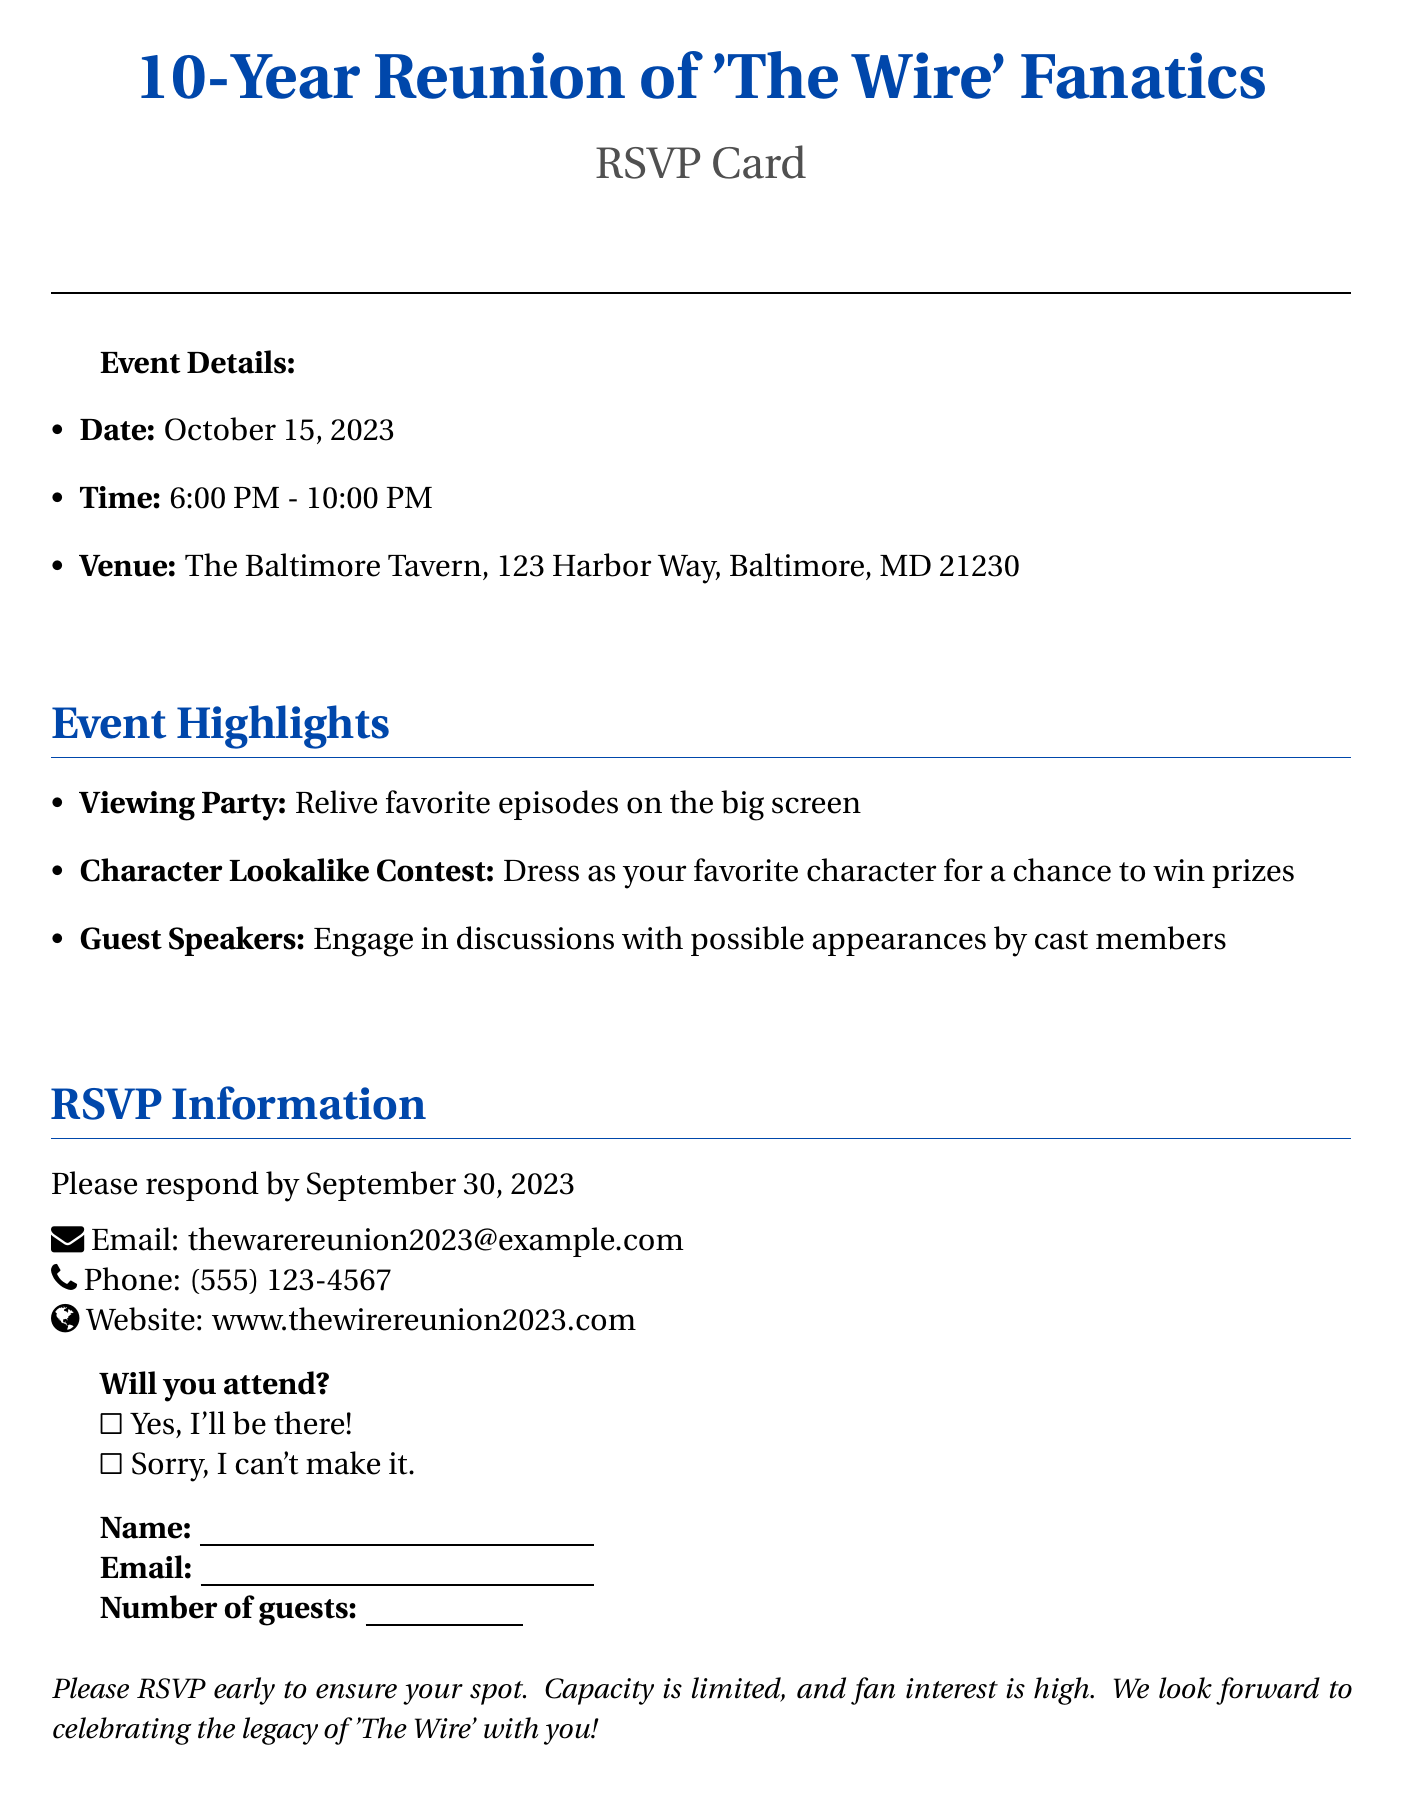What is the date of the reunion? The document specifies the event date as October 15, 2023.
Answer: October 15, 2023 What time does the event start? The start time of the event listed in the document is 6:00 PM.
Answer: 6:00 PM Where is the venue located? The venue address provided in the document is The Baltimore Tavern, 123 Harbor Way, Baltimore, MD 21230.
Answer: The Baltimore Tavern, 123 Harbor Way, Baltimore, MD 21230 What is one of the event highlights? The document lists a viewing party, character lookalike contest, and guest speakers as highlights.
Answer: Viewing Party When is the RSVP deadline? The deadline for RSVPs mentioned in the document is September 30, 2023.
Answer: September 30, 2023 Can you RSVP by phone? The document includes a phone contact for RSVP, indicating you can RSVP by phone.
Answer: Yes What should you do if you want to attend? The document indicates that attendees should respond with "Yes, I'll be there!" on the RSVP.
Answer: Respond with "Yes, I'll be there!" Is there a character lookalike contest? The document specifically mentions a character lookalike contest as one of the event highlights.
Answer: Yes 